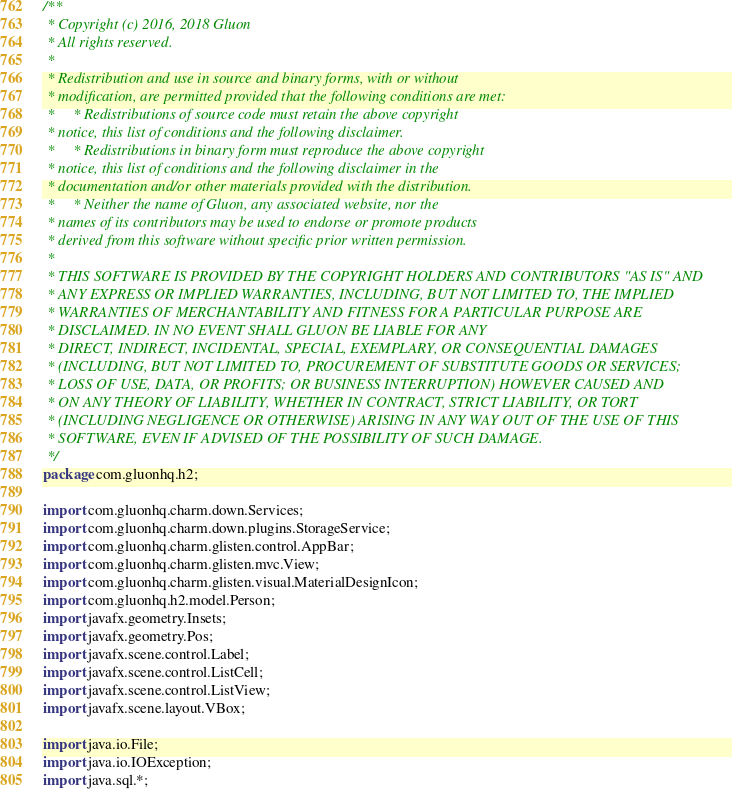<code> <loc_0><loc_0><loc_500><loc_500><_Java_>/**
 * Copyright (c) 2016, 2018 Gluon
 * All rights reserved.
 *
 * Redistribution and use in source and binary forms, with or without
 * modification, are permitted provided that the following conditions are met:
 *     * Redistributions of source code must retain the above copyright
 * notice, this list of conditions and the following disclaimer.
 *     * Redistributions in binary form must reproduce the above copyright
 * notice, this list of conditions and the following disclaimer in the
 * documentation and/or other materials provided with the distribution.
 *     * Neither the name of Gluon, any associated website, nor the
 * names of its contributors may be used to endorse or promote products
 * derived from this software without specific prior written permission.
 *
 * THIS SOFTWARE IS PROVIDED BY THE COPYRIGHT HOLDERS AND CONTRIBUTORS "AS IS" AND
 * ANY EXPRESS OR IMPLIED WARRANTIES, INCLUDING, BUT NOT LIMITED TO, THE IMPLIED
 * WARRANTIES OF MERCHANTABILITY AND FITNESS FOR A PARTICULAR PURPOSE ARE
 * DISCLAIMED. IN NO EVENT SHALL GLUON BE LIABLE FOR ANY
 * DIRECT, INDIRECT, INCIDENTAL, SPECIAL, EXEMPLARY, OR CONSEQUENTIAL DAMAGES
 * (INCLUDING, BUT NOT LIMITED TO, PROCUREMENT OF SUBSTITUTE GOODS OR SERVICES;
 * LOSS OF USE, DATA, OR PROFITS; OR BUSINESS INTERRUPTION) HOWEVER CAUSED AND
 * ON ANY THEORY OF LIABILITY, WHETHER IN CONTRACT, STRICT LIABILITY, OR TORT
 * (INCLUDING NEGLIGENCE OR OTHERWISE) ARISING IN ANY WAY OUT OF THE USE OF THIS
 * SOFTWARE, EVEN IF ADVISED OF THE POSSIBILITY OF SUCH DAMAGE.
 */
package com.gluonhq.h2;

import com.gluonhq.charm.down.Services;
import com.gluonhq.charm.down.plugins.StorageService;
import com.gluonhq.charm.glisten.control.AppBar;
import com.gluonhq.charm.glisten.mvc.View;
import com.gluonhq.charm.glisten.visual.MaterialDesignIcon;
import com.gluonhq.h2.model.Person;
import javafx.geometry.Insets;
import javafx.geometry.Pos;
import javafx.scene.control.Label;
import javafx.scene.control.ListCell;
import javafx.scene.control.ListView;
import javafx.scene.layout.VBox;

import java.io.File;
import java.io.IOException;
import java.sql.*;</code> 